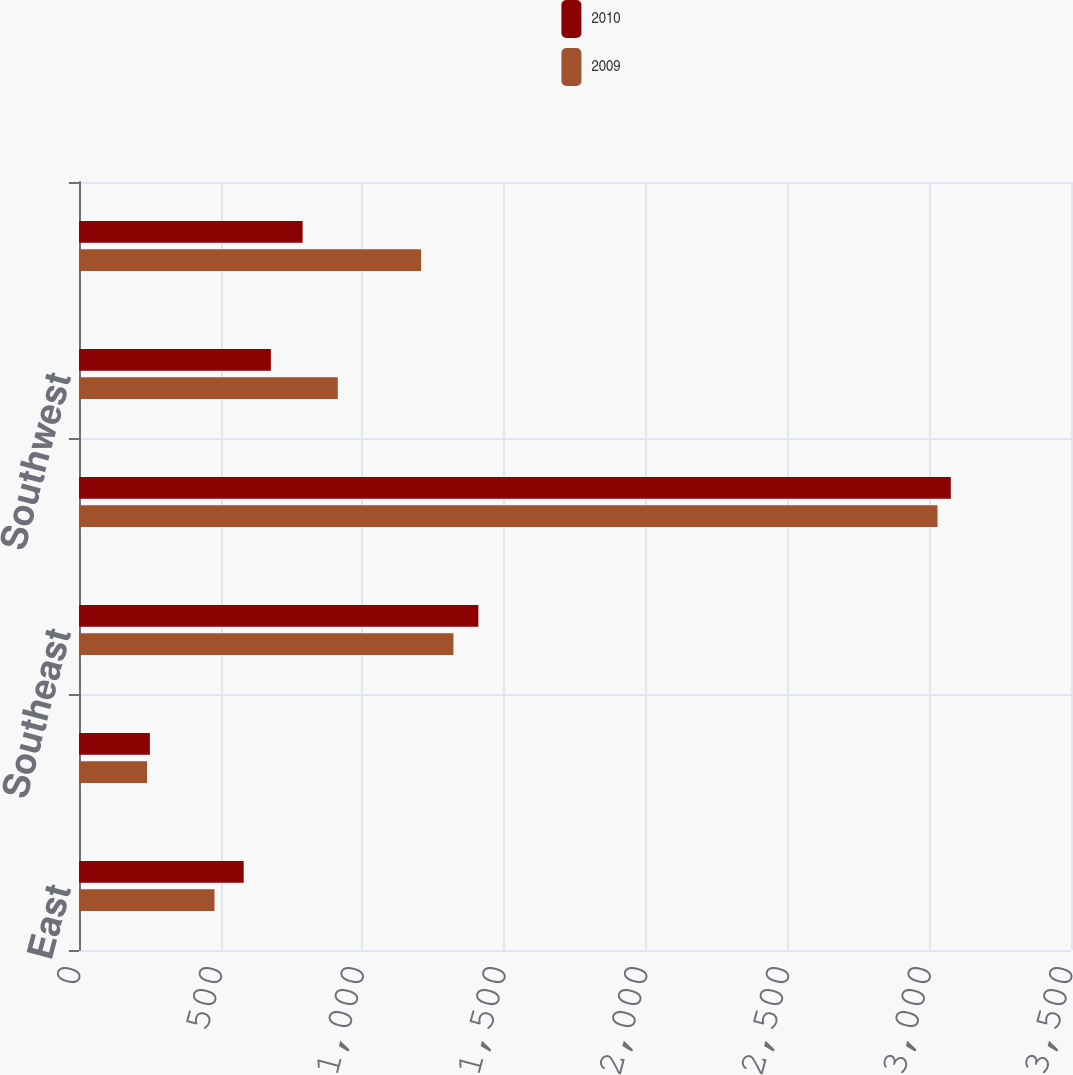Convert chart. <chart><loc_0><loc_0><loc_500><loc_500><stacked_bar_chart><ecel><fcel>East<fcel>Midwest<fcel>Southeast<fcel>South Central<fcel>Southwest<fcel>West<nl><fcel>2010<fcel>581<fcel>250<fcel>1409<fcel>3076<fcel>677<fcel>789<nl><fcel>2009<fcel>478<fcel>240<fcel>1321<fcel>3029<fcel>913<fcel>1207<nl></chart> 